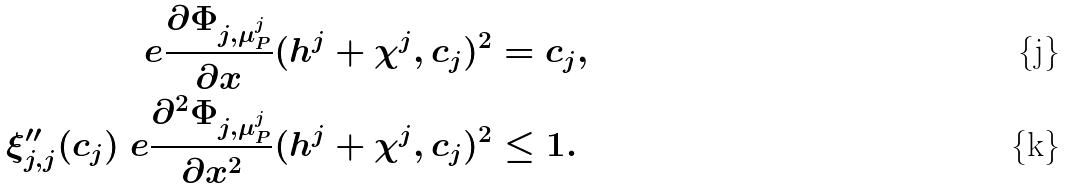Convert formula to latex. <formula><loc_0><loc_0><loc_500><loc_500>\ e \frac { \partial \Phi _ { j , \mu _ { P } ^ { j } } } { \partial x } ( h ^ { j } + \chi ^ { j } , c _ { j } ) ^ { 2 } & = c _ { j } , \\ \xi _ { j , j } ^ { \prime \prime } ( c _ { j } ) \ e \frac { \partial ^ { 2 } \Phi _ { j , \mu _ { P } ^ { j } } } { \partial x ^ { 2 } } ( h ^ { j } + \chi ^ { j } , c _ { j } ) ^ { 2 } & \leq 1 .</formula> 